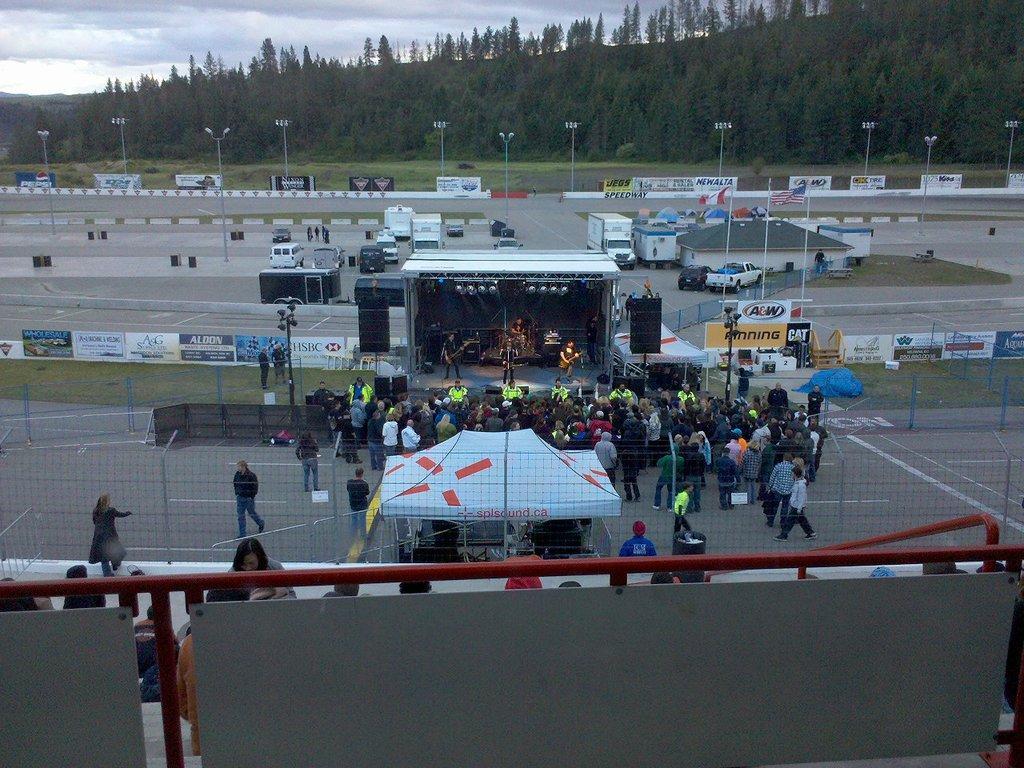How would you summarize this image in a sentence or two? In this image I can see the group of people standing and wearing the different color dresses. To the side of these people I can see the tent and few people playing the musical instruments and these people are on the stage. To the side of the stage I can see the poles and many boards. There is a net in the front. In the background I can see many vehicles and the shed. I can also see many poles, boards, flags, trees and the sky. 